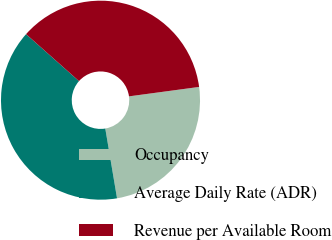Convert chart to OTSL. <chart><loc_0><loc_0><loc_500><loc_500><pie_chart><fcel>Occupancy<fcel>Average Daily Rate (ADR)<fcel>Revenue per Available Room<nl><fcel>24.47%<fcel>39.21%<fcel>36.32%<nl></chart> 